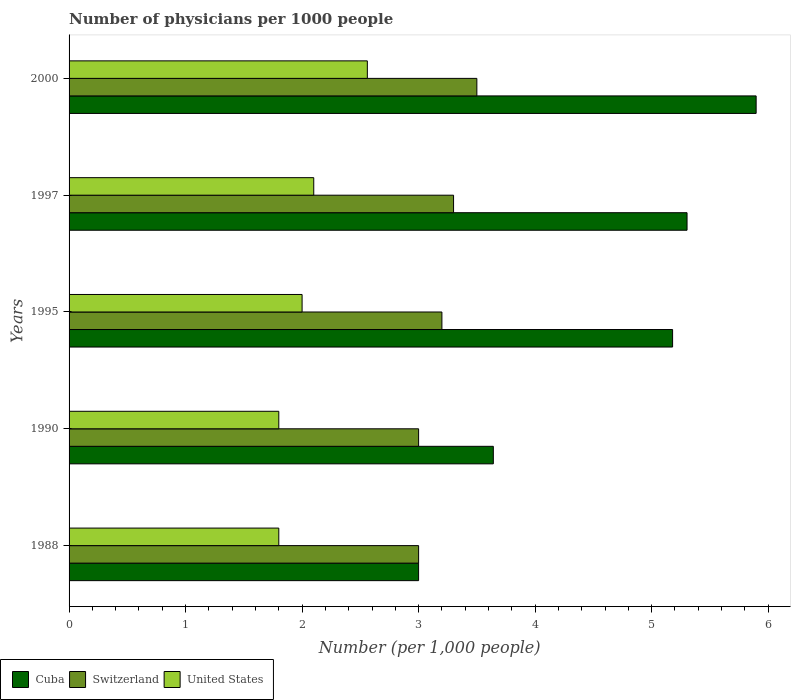Are the number of bars per tick equal to the number of legend labels?
Provide a short and direct response. Yes. Are the number of bars on each tick of the Y-axis equal?
Offer a very short reply. Yes. How many bars are there on the 1st tick from the top?
Give a very brief answer. 3. How many bars are there on the 1st tick from the bottom?
Your answer should be compact. 3. What is the label of the 4th group of bars from the top?
Offer a terse response. 1990. Across all years, what is the minimum number of physicians in Switzerland?
Provide a succinct answer. 3. What is the difference between the number of physicians in Switzerland in 1988 and that in 1990?
Your answer should be compact. 0. What is the average number of physicians in Cuba per year?
Provide a short and direct response. 4.6. In how many years, is the number of physicians in Cuba greater than 3 ?
Your response must be concise. 4. What is the ratio of the number of physicians in United States in 1990 to that in 2000?
Provide a succinct answer. 0.7. Is the number of physicians in United States in 1995 less than that in 1997?
Offer a terse response. Yes. Is the difference between the number of physicians in United States in 1988 and 1990 greater than the difference between the number of physicians in Switzerland in 1988 and 1990?
Provide a short and direct response. No. What is the difference between the highest and the second highest number of physicians in Cuba?
Your answer should be compact. 0.59. What is the difference between the highest and the lowest number of physicians in Switzerland?
Your answer should be very brief. 0.5. In how many years, is the number of physicians in Switzerland greater than the average number of physicians in Switzerland taken over all years?
Offer a very short reply. 2. Is it the case that in every year, the sum of the number of physicians in Cuba and number of physicians in Switzerland is greater than the number of physicians in United States?
Your answer should be compact. Yes. Are all the bars in the graph horizontal?
Ensure brevity in your answer.  Yes. How many years are there in the graph?
Your answer should be very brief. 5. Are the values on the major ticks of X-axis written in scientific E-notation?
Your response must be concise. No. Does the graph contain any zero values?
Keep it short and to the point. No. Does the graph contain grids?
Provide a succinct answer. No. Where does the legend appear in the graph?
Ensure brevity in your answer.  Bottom left. What is the title of the graph?
Ensure brevity in your answer.  Number of physicians per 1000 people. What is the label or title of the X-axis?
Provide a succinct answer. Number (per 1,0 people). What is the label or title of the Y-axis?
Keep it short and to the point. Years. What is the Number (per 1,000 people) of Cuba in 1988?
Give a very brief answer. 3. What is the Number (per 1,000 people) in Switzerland in 1988?
Offer a very short reply. 3. What is the Number (per 1,000 people) of Cuba in 1990?
Offer a very short reply. 3.64. What is the Number (per 1,000 people) in Switzerland in 1990?
Offer a terse response. 3. What is the Number (per 1,000 people) in United States in 1990?
Give a very brief answer. 1.8. What is the Number (per 1,000 people) in Cuba in 1995?
Keep it short and to the point. 5.18. What is the Number (per 1,000 people) of Switzerland in 1995?
Your answer should be compact. 3.2. What is the Number (per 1,000 people) of United States in 1995?
Provide a short and direct response. 2. What is the Number (per 1,000 people) in Cuba in 1997?
Offer a very short reply. 5.3. What is the Number (per 1,000 people) in Switzerland in 1997?
Your response must be concise. 3.3. What is the Number (per 1,000 people) of United States in 1997?
Provide a short and direct response. 2.1. What is the Number (per 1,000 people) in Cuba in 2000?
Ensure brevity in your answer.  5.9. What is the Number (per 1,000 people) in Switzerland in 2000?
Give a very brief answer. 3.5. What is the Number (per 1,000 people) of United States in 2000?
Your response must be concise. 2.56. Across all years, what is the maximum Number (per 1,000 people) in Cuba?
Provide a short and direct response. 5.9. Across all years, what is the maximum Number (per 1,000 people) of United States?
Offer a very short reply. 2.56. Across all years, what is the minimum Number (per 1,000 people) of Cuba?
Keep it short and to the point. 3. Across all years, what is the minimum Number (per 1,000 people) in Switzerland?
Ensure brevity in your answer.  3. Across all years, what is the minimum Number (per 1,000 people) in United States?
Provide a short and direct response. 1.8. What is the total Number (per 1,000 people) in Cuba in the graph?
Provide a short and direct response. 23.02. What is the total Number (per 1,000 people) in United States in the graph?
Make the answer very short. 10.26. What is the difference between the Number (per 1,000 people) of Cuba in 1988 and that in 1990?
Make the answer very short. -0.64. What is the difference between the Number (per 1,000 people) in Switzerland in 1988 and that in 1990?
Make the answer very short. 0. What is the difference between the Number (per 1,000 people) in United States in 1988 and that in 1990?
Your response must be concise. 0. What is the difference between the Number (per 1,000 people) in Cuba in 1988 and that in 1995?
Your answer should be very brief. -2.18. What is the difference between the Number (per 1,000 people) in United States in 1988 and that in 1995?
Make the answer very short. -0.2. What is the difference between the Number (per 1,000 people) in Cuba in 1988 and that in 1997?
Provide a short and direct response. -2.3. What is the difference between the Number (per 1,000 people) in Cuba in 1988 and that in 2000?
Make the answer very short. -2.9. What is the difference between the Number (per 1,000 people) of United States in 1988 and that in 2000?
Give a very brief answer. -0.76. What is the difference between the Number (per 1,000 people) in Cuba in 1990 and that in 1995?
Offer a very short reply. -1.54. What is the difference between the Number (per 1,000 people) of United States in 1990 and that in 1995?
Ensure brevity in your answer.  -0.2. What is the difference between the Number (per 1,000 people) in Cuba in 1990 and that in 1997?
Offer a terse response. -1.66. What is the difference between the Number (per 1,000 people) in Switzerland in 1990 and that in 1997?
Offer a terse response. -0.3. What is the difference between the Number (per 1,000 people) of United States in 1990 and that in 1997?
Your response must be concise. -0.3. What is the difference between the Number (per 1,000 people) of Cuba in 1990 and that in 2000?
Ensure brevity in your answer.  -2.26. What is the difference between the Number (per 1,000 people) in United States in 1990 and that in 2000?
Your response must be concise. -0.76. What is the difference between the Number (per 1,000 people) in Cuba in 1995 and that in 1997?
Give a very brief answer. -0.12. What is the difference between the Number (per 1,000 people) in United States in 1995 and that in 1997?
Provide a short and direct response. -0.1. What is the difference between the Number (per 1,000 people) of Cuba in 1995 and that in 2000?
Your answer should be very brief. -0.72. What is the difference between the Number (per 1,000 people) in Switzerland in 1995 and that in 2000?
Offer a terse response. -0.3. What is the difference between the Number (per 1,000 people) in United States in 1995 and that in 2000?
Your answer should be compact. -0.56. What is the difference between the Number (per 1,000 people) in Cuba in 1997 and that in 2000?
Offer a very short reply. -0.59. What is the difference between the Number (per 1,000 people) of Switzerland in 1997 and that in 2000?
Provide a succinct answer. -0.2. What is the difference between the Number (per 1,000 people) of United States in 1997 and that in 2000?
Provide a short and direct response. -0.46. What is the difference between the Number (per 1,000 people) of Cuba in 1988 and the Number (per 1,000 people) of Switzerland in 1990?
Provide a short and direct response. -0. What is the difference between the Number (per 1,000 people) in Cuba in 1988 and the Number (per 1,000 people) in United States in 1990?
Provide a succinct answer. 1.2. What is the difference between the Number (per 1,000 people) of Cuba in 1988 and the Number (per 1,000 people) of Switzerland in 1995?
Keep it short and to the point. -0.2. What is the difference between the Number (per 1,000 people) in Cuba in 1988 and the Number (per 1,000 people) in Switzerland in 1997?
Offer a very short reply. -0.3. What is the difference between the Number (per 1,000 people) of Cuba in 1988 and the Number (per 1,000 people) of United States in 1997?
Your response must be concise. 0.9. What is the difference between the Number (per 1,000 people) of Switzerland in 1988 and the Number (per 1,000 people) of United States in 1997?
Offer a terse response. 0.9. What is the difference between the Number (per 1,000 people) in Cuba in 1988 and the Number (per 1,000 people) in Switzerland in 2000?
Make the answer very short. -0.5. What is the difference between the Number (per 1,000 people) of Cuba in 1988 and the Number (per 1,000 people) of United States in 2000?
Provide a succinct answer. 0.44. What is the difference between the Number (per 1,000 people) in Switzerland in 1988 and the Number (per 1,000 people) in United States in 2000?
Offer a very short reply. 0.44. What is the difference between the Number (per 1,000 people) in Cuba in 1990 and the Number (per 1,000 people) in Switzerland in 1995?
Your response must be concise. 0.44. What is the difference between the Number (per 1,000 people) of Cuba in 1990 and the Number (per 1,000 people) of United States in 1995?
Offer a very short reply. 1.64. What is the difference between the Number (per 1,000 people) of Cuba in 1990 and the Number (per 1,000 people) of Switzerland in 1997?
Keep it short and to the point. 0.34. What is the difference between the Number (per 1,000 people) of Cuba in 1990 and the Number (per 1,000 people) of United States in 1997?
Ensure brevity in your answer.  1.54. What is the difference between the Number (per 1,000 people) of Cuba in 1990 and the Number (per 1,000 people) of Switzerland in 2000?
Provide a short and direct response. 0.14. What is the difference between the Number (per 1,000 people) of Cuba in 1990 and the Number (per 1,000 people) of United States in 2000?
Offer a very short reply. 1.08. What is the difference between the Number (per 1,000 people) of Switzerland in 1990 and the Number (per 1,000 people) of United States in 2000?
Your response must be concise. 0.44. What is the difference between the Number (per 1,000 people) of Cuba in 1995 and the Number (per 1,000 people) of Switzerland in 1997?
Give a very brief answer. 1.88. What is the difference between the Number (per 1,000 people) of Cuba in 1995 and the Number (per 1,000 people) of United States in 1997?
Your answer should be very brief. 3.08. What is the difference between the Number (per 1,000 people) of Switzerland in 1995 and the Number (per 1,000 people) of United States in 1997?
Provide a short and direct response. 1.1. What is the difference between the Number (per 1,000 people) in Cuba in 1995 and the Number (per 1,000 people) in Switzerland in 2000?
Give a very brief answer. 1.68. What is the difference between the Number (per 1,000 people) in Cuba in 1995 and the Number (per 1,000 people) in United States in 2000?
Ensure brevity in your answer.  2.62. What is the difference between the Number (per 1,000 people) in Switzerland in 1995 and the Number (per 1,000 people) in United States in 2000?
Your answer should be very brief. 0.64. What is the difference between the Number (per 1,000 people) in Cuba in 1997 and the Number (per 1,000 people) in Switzerland in 2000?
Give a very brief answer. 1.8. What is the difference between the Number (per 1,000 people) in Cuba in 1997 and the Number (per 1,000 people) in United States in 2000?
Your answer should be very brief. 2.74. What is the difference between the Number (per 1,000 people) of Switzerland in 1997 and the Number (per 1,000 people) of United States in 2000?
Ensure brevity in your answer.  0.74. What is the average Number (per 1,000 people) in Cuba per year?
Keep it short and to the point. 4.6. What is the average Number (per 1,000 people) of Switzerland per year?
Your answer should be very brief. 3.2. What is the average Number (per 1,000 people) of United States per year?
Provide a succinct answer. 2.05. In the year 1988, what is the difference between the Number (per 1,000 people) in Cuba and Number (per 1,000 people) in Switzerland?
Give a very brief answer. -0. In the year 1988, what is the difference between the Number (per 1,000 people) of Cuba and Number (per 1,000 people) of United States?
Ensure brevity in your answer.  1.2. In the year 1988, what is the difference between the Number (per 1,000 people) in Switzerland and Number (per 1,000 people) in United States?
Keep it short and to the point. 1.2. In the year 1990, what is the difference between the Number (per 1,000 people) in Cuba and Number (per 1,000 people) in Switzerland?
Make the answer very short. 0.64. In the year 1990, what is the difference between the Number (per 1,000 people) in Cuba and Number (per 1,000 people) in United States?
Your response must be concise. 1.84. In the year 1995, what is the difference between the Number (per 1,000 people) of Cuba and Number (per 1,000 people) of Switzerland?
Offer a terse response. 1.98. In the year 1995, what is the difference between the Number (per 1,000 people) of Cuba and Number (per 1,000 people) of United States?
Make the answer very short. 3.18. In the year 1997, what is the difference between the Number (per 1,000 people) in Cuba and Number (per 1,000 people) in Switzerland?
Offer a terse response. 2. In the year 1997, what is the difference between the Number (per 1,000 people) of Cuba and Number (per 1,000 people) of United States?
Ensure brevity in your answer.  3.2. In the year 2000, what is the difference between the Number (per 1,000 people) of Cuba and Number (per 1,000 people) of Switzerland?
Keep it short and to the point. 2.4. In the year 2000, what is the difference between the Number (per 1,000 people) in Cuba and Number (per 1,000 people) in United States?
Make the answer very short. 3.34. In the year 2000, what is the difference between the Number (per 1,000 people) of Switzerland and Number (per 1,000 people) of United States?
Ensure brevity in your answer.  0.94. What is the ratio of the Number (per 1,000 people) in Cuba in 1988 to that in 1990?
Provide a succinct answer. 0.82. What is the ratio of the Number (per 1,000 people) in Cuba in 1988 to that in 1995?
Your answer should be compact. 0.58. What is the ratio of the Number (per 1,000 people) of Switzerland in 1988 to that in 1995?
Your response must be concise. 0.94. What is the ratio of the Number (per 1,000 people) of United States in 1988 to that in 1995?
Your answer should be very brief. 0.9. What is the ratio of the Number (per 1,000 people) in Cuba in 1988 to that in 1997?
Offer a terse response. 0.57. What is the ratio of the Number (per 1,000 people) in United States in 1988 to that in 1997?
Your answer should be compact. 0.86. What is the ratio of the Number (per 1,000 people) in Cuba in 1988 to that in 2000?
Ensure brevity in your answer.  0.51. What is the ratio of the Number (per 1,000 people) of United States in 1988 to that in 2000?
Your response must be concise. 0.7. What is the ratio of the Number (per 1,000 people) in Cuba in 1990 to that in 1995?
Provide a short and direct response. 0.7. What is the ratio of the Number (per 1,000 people) in United States in 1990 to that in 1995?
Your answer should be compact. 0.9. What is the ratio of the Number (per 1,000 people) in Cuba in 1990 to that in 1997?
Your answer should be compact. 0.69. What is the ratio of the Number (per 1,000 people) of Cuba in 1990 to that in 2000?
Make the answer very short. 0.62. What is the ratio of the Number (per 1,000 people) in Switzerland in 1990 to that in 2000?
Your response must be concise. 0.86. What is the ratio of the Number (per 1,000 people) in United States in 1990 to that in 2000?
Provide a short and direct response. 0.7. What is the ratio of the Number (per 1,000 people) of Cuba in 1995 to that in 1997?
Your answer should be compact. 0.98. What is the ratio of the Number (per 1,000 people) of Switzerland in 1995 to that in 1997?
Give a very brief answer. 0.97. What is the ratio of the Number (per 1,000 people) of Cuba in 1995 to that in 2000?
Your answer should be compact. 0.88. What is the ratio of the Number (per 1,000 people) of Switzerland in 1995 to that in 2000?
Keep it short and to the point. 0.91. What is the ratio of the Number (per 1,000 people) of United States in 1995 to that in 2000?
Provide a short and direct response. 0.78. What is the ratio of the Number (per 1,000 people) of Cuba in 1997 to that in 2000?
Give a very brief answer. 0.9. What is the ratio of the Number (per 1,000 people) in Switzerland in 1997 to that in 2000?
Your answer should be very brief. 0.94. What is the ratio of the Number (per 1,000 people) in United States in 1997 to that in 2000?
Ensure brevity in your answer.  0.82. What is the difference between the highest and the second highest Number (per 1,000 people) of Cuba?
Provide a short and direct response. 0.59. What is the difference between the highest and the second highest Number (per 1,000 people) in United States?
Your answer should be compact. 0.46. What is the difference between the highest and the lowest Number (per 1,000 people) in Cuba?
Offer a very short reply. 2.9. What is the difference between the highest and the lowest Number (per 1,000 people) of United States?
Your answer should be compact. 0.76. 